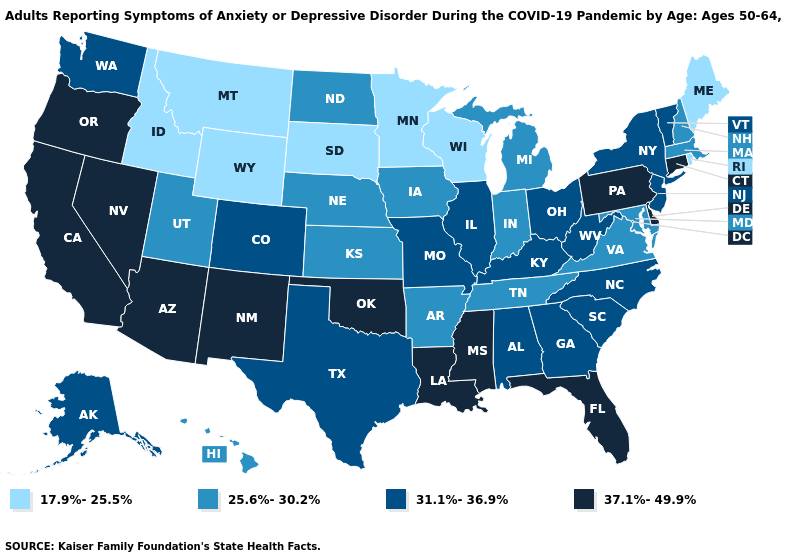What is the value of Tennessee?
Concise answer only. 25.6%-30.2%. Name the states that have a value in the range 37.1%-49.9%?
Write a very short answer. Arizona, California, Connecticut, Delaware, Florida, Louisiana, Mississippi, Nevada, New Mexico, Oklahoma, Oregon, Pennsylvania. Name the states that have a value in the range 25.6%-30.2%?
Answer briefly. Arkansas, Hawaii, Indiana, Iowa, Kansas, Maryland, Massachusetts, Michigan, Nebraska, New Hampshire, North Dakota, Tennessee, Utah, Virginia. How many symbols are there in the legend?
Write a very short answer. 4. What is the value of Maine?
Quick response, please. 17.9%-25.5%. Does the map have missing data?
Be succinct. No. Does Alaska have the highest value in the West?
Concise answer only. No. What is the lowest value in states that border Maine?
Give a very brief answer. 25.6%-30.2%. What is the value of Rhode Island?
Concise answer only. 17.9%-25.5%. Name the states that have a value in the range 25.6%-30.2%?
Concise answer only. Arkansas, Hawaii, Indiana, Iowa, Kansas, Maryland, Massachusetts, Michigan, Nebraska, New Hampshire, North Dakota, Tennessee, Utah, Virginia. What is the lowest value in states that border Rhode Island?
Answer briefly. 25.6%-30.2%. Does Missouri have the highest value in the MidWest?
Keep it brief. Yes. Among the states that border Louisiana , does Texas have the highest value?
Answer briefly. No. Does Louisiana have the highest value in the South?
Write a very short answer. Yes. Which states hav the highest value in the South?
Short answer required. Delaware, Florida, Louisiana, Mississippi, Oklahoma. 